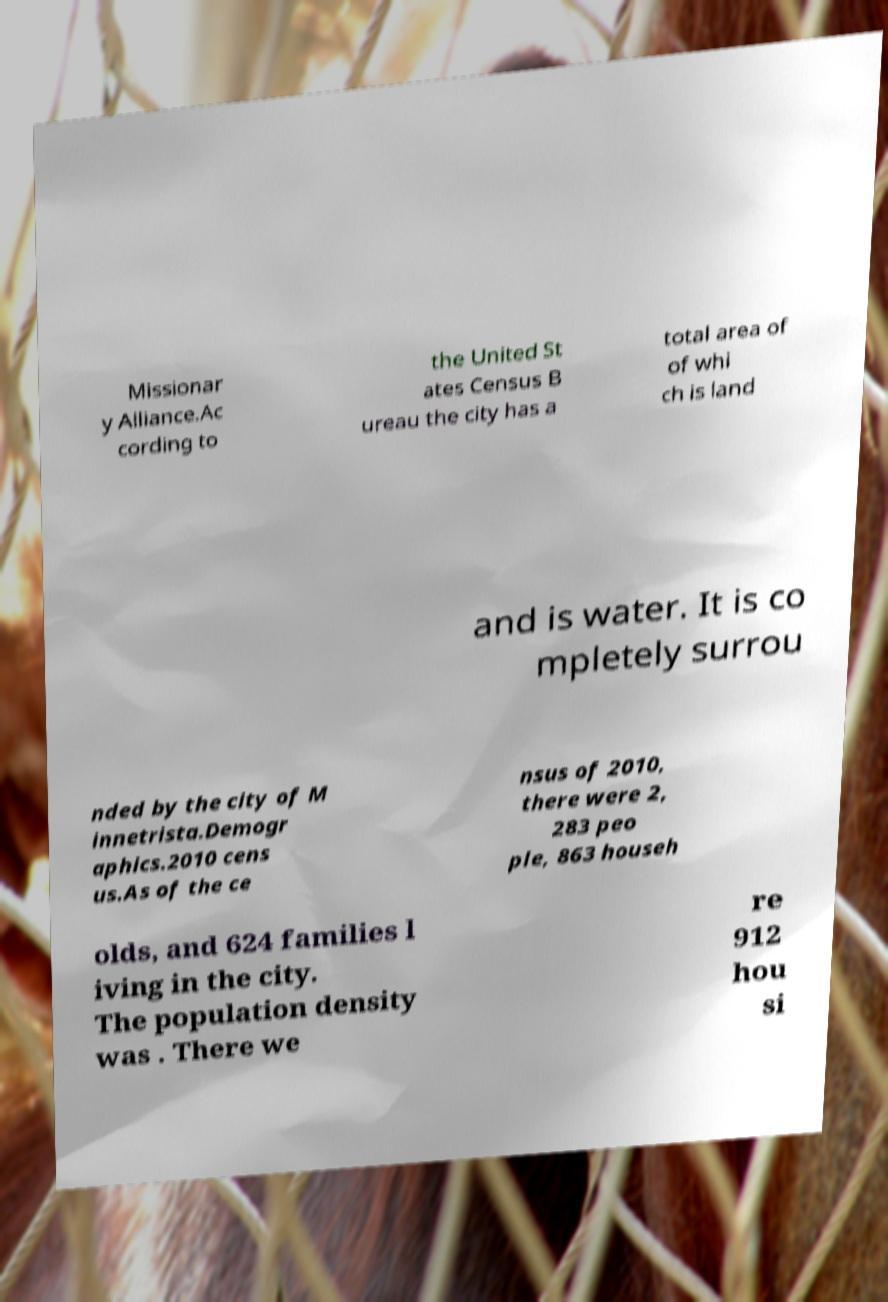Could you extract and type out the text from this image? Missionar y Alliance.Ac cording to the United St ates Census B ureau the city has a total area of of whi ch is land and is water. It is co mpletely surrou nded by the city of M innetrista.Demogr aphics.2010 cens us.As of the ce nsus of 2010, there were 2, 283 peo ple, 863 househ olds, and 624 families l iving in the city. The population density was . There we re 912 hou si 